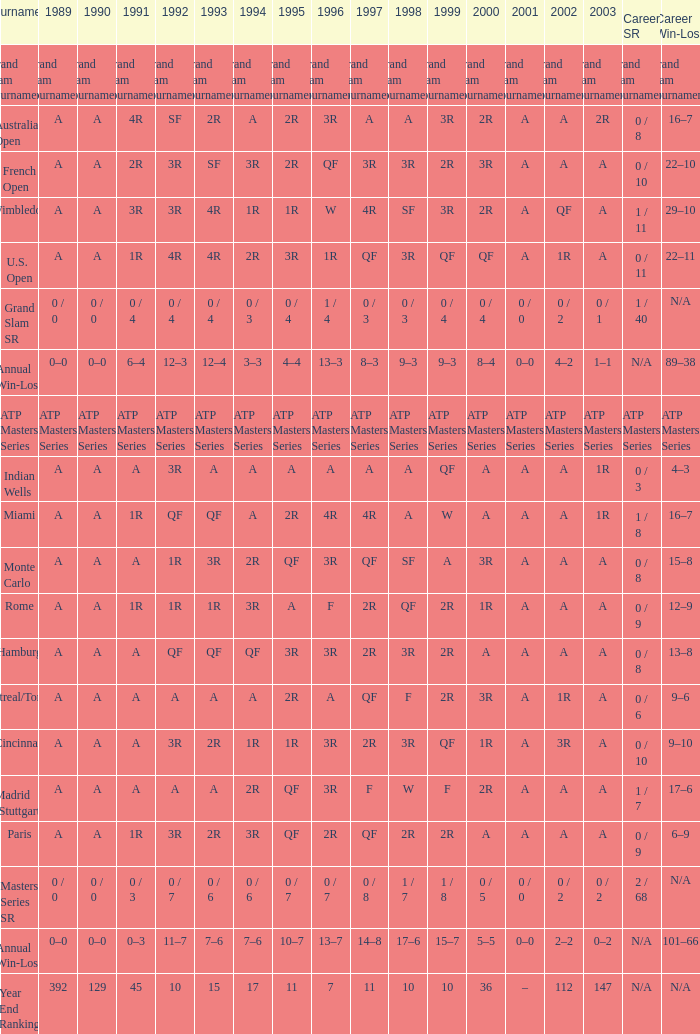In 1989, what was the value, taking into account qf from 1997 and a from 1993? A. Can you give me this table as a dict? {'header': ['Tournament', '1989', '1990', '1991', '1992', '1993', '1994', '1995', '1996', '1997', '1998', '1999', '2000', '2001', '2002', '2003', 'Career SR', 'Career Win-Loss'], 'rows': [['Grand Slam Tournaments', 'Grand Slam Tournaments', 'Grand Slam Tournaments', 'Grand Slam Tournaments', 'Grand Slam Tournaments', 'Grand Slam Tournaments', 'Grand Slam Tournaments', 'Grand Slam Tournaments', 'Grand Slam Tournaments', 'Grand Slam Tournaments', 'Grand Slam Tournaments', 'Grand Slam Tournaments', 'Grand Slam Tournaments', 'Grand Slam Tournaments', 'Grand Slam Tournaments', 'Grand Slam Tournaments', 'Grand Slam Tournaments', 'Grand Slam Tournaments'], ['Australian Open', 'A', 'A', '4R', 'SF', '2R', 'A', '2R', '3R', 'A', 'A', '3R', '2R', 'A', 'A', '2R', '0 / 8', '16–7'], ['French Open', 'A', 'A', '2R', '3R', 'SF', '3R', '2R', 'QF', '3R', '3R', '2R', '3R', 'A', 'A', 'A', '0 / 10', '22–10'], ['Wimbledon', 'A', 'A', '3R', '3R', '4R', '1R', '1R', 'W', '4R', 'SF', '3R', '2R', 'A', 'QF', 'A', '1 / 11', '29–10'], ['U.S. Open', 'A', 'A', '1R', '4R', '4R', '2R', '3R', '1R', 'QF', '3R', 'QF', 'QF', 'A', '1R', 'A', '0 / 11', '22–11'], ['Grand Slam SR', '0 / 0', '0 / 0', '0 / 4', '0 / 4', '0 / 4', '0 / 3', '0 / 4', '1 / 4', '0 / 3', '0 / 3', '0 / 4', '0 / 4', '0 / 0', '0 / 2', '0 / 1', '1 / 40', 'N/A'], ['Annual Win-Loss', '0–0', '0–0', '6–4', '12–3', '12–4', '3–3', '4–4', '13–3', '8–3', '9–3', '9–3', '8–4', '0–0', '4–2', '1–1', 'N/A', '89–38'], ['ATP Masters Series', 'ATP Masters Series', 'ATP Masters Series', 'ATP Masters Series', 'ATP Masters Series', 'ATP Masters Series', 'ATP Masters Series', 'ATP Masters Series', 'ATP Masters Series', 'ATP Masters Series', 'ATP Masters Series', 'ATP Masters Series', 'ATP Masters Series', 'ATP Masters Series', 'ATP Masters Series', 'ATP Masters Series', 'ATP Masters Series', 'ATP Masters Series'], ['Indian Wells', 'A', 'A', 'A', '3R', 'A', 'A', 'A', 'A', 'A', 'A', 'QF', 'A', 'A', 'A', '1R', '0 / 3', '4–3'], ['Miami', 'A', 'A', '1R', 'QF', 'QF', 'A', '2R', '4R', '4R', 'A', 'W', 'A', 'A', 'A', '1R', '1 / 8', '16–7'], ['Monte Carlo', 'A', 'A', 'A', '1R', '3R', '2R', 'QF', '3R', 'QF', 'SF', 'A', '3R', 'A', 'A', 'A', '0 / 8', '15–8'], ['Rome', 'A', 'A', '1R', '1R', '1R', '3R', 'A', 'F', '2R', 'QF', '2R', '1R', 'A', 'A', 'A', '0 / 9', '12–9'], ['Hamburg', 'A', 'A', 'A', 'QF', 'QF', 'QF', '3R', '3R', '2R', '3R', '2R', 'A', 'A', 'A', 'A', '0 / 8', '13–8'], ['Montreal/Toronto', 'A', 'A', 'A', 'A', 'A', 'A', '2R', 'A', 'QF', 'F', '2R', '3R', 'A', '1R', 'A', '0 / 6', '9–6'], ['Cincinnati', 'A', 'A', 'A', '3R', '2R', '1R', '1R', '3R', '2R', '3R', 'QF', '1R', 'A', '3R', 'A', '0 / 10', '9–10'], ['Madrid (Stuttgart)', 'A', 'A', 'A', 'A', 'A', '2R', 'QF', '3R', 'F', 'W', 'F', '2R', 'A', 'A', 'A', '1 / 7', '17–6'], ['Paris', 'A', 'A', '1R', '3R', '2R', '3R', 'QF', '2R', 'QF', '2R', '2R', 'A', 'A', 'A', 'A', '0 / 9', '6–9'], ['Masters Series SR', '0 / 0', '0 / 0', '0 / 3', '0 / 7', '0 / 6', '0 / 6', '0 / 7', '0 / 7', '0 / 8', '1 / 7', '1 / 8', '0 / 5', '0 / 0', '0 / 2', '0 / 2', '2 / 68', 'N/A'], ['Annual Win-Loss', '0–0', '0–0', '0–3', '11–7', '7–6', '7–6', '10–7', '13–7', '14–8', '17–6', '15–7', '5–5', '0–0', '2–2', '0–2', 'N/A', '101–66'], ['Year End Ranking', '392', '129', '45', '10', '15', '17', '11', '7', '11', '10', '10', '36', '–', '112', '147', 'N/A', 'N/A']]} 